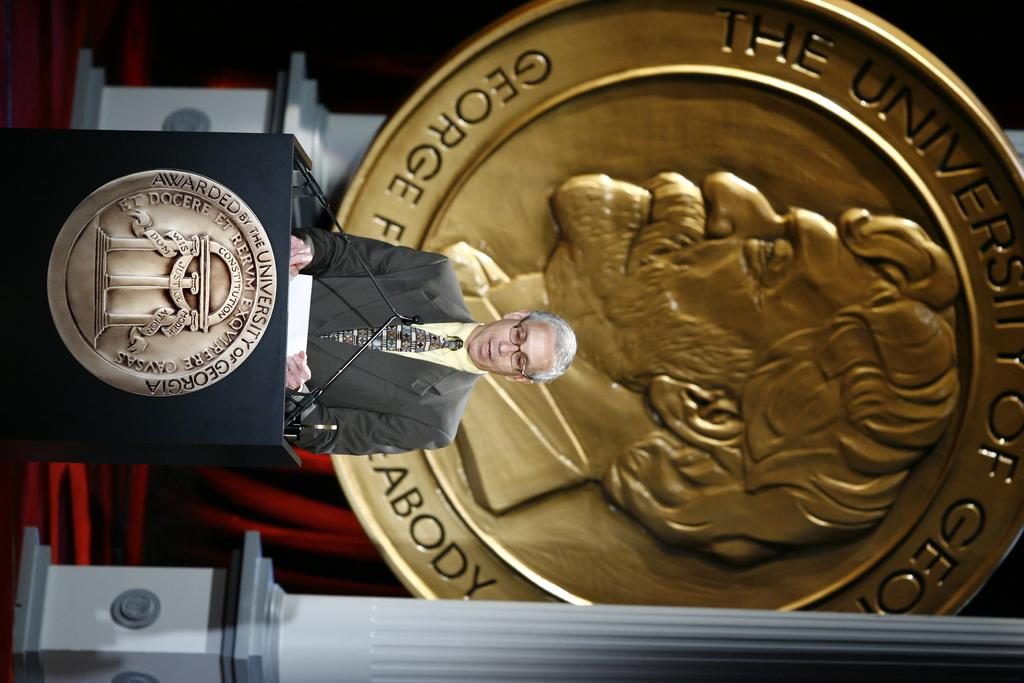What is the person in the image doing? There is a person standing at the podium in the image. What is attached to the podium? Mics are attached to the podium. What can be seen in the background of the image? There is an emblem and a curtain in the background, as well as poles. What type of ocean can be seen in the background of the image? There is no ocean present in the image; it features a person at a podium with a background containing an emblem, curtain, and poles. What holiday songs are being sung by the person at the podium? There is no indication in the image that the person is singing any songs, let alone holiday songs. 